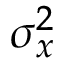Convert formula to latex. <formula><loc_0><loc_0><loc_500><loc_500>\sigma _ { x } ^ { 2 }</formula> 